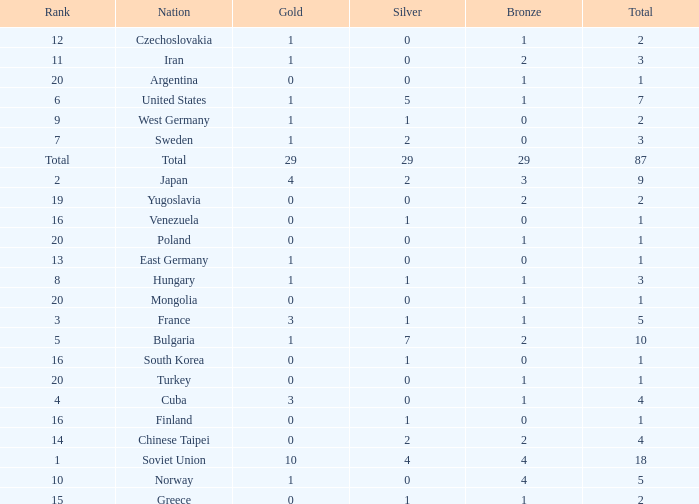What is the average number of bronze medals for total of all nations? 29.0. Could you help me parse every detail presented in this table? {'header': ['Rank', 'Nation', 'Gold', 'Silver', 'Bronze', 'Total'], 'rows': [['12', 'Czechoslovakia', '1', '0', '1', '2'], ['11', 'Iran', '1', '0', '2', '3'], ['20', 'Argentina', '0', '0', '1', '1'], ['6', 'United States', '1', '5', '1', '7'], ['9', 'West Germany', '1', '1', '0', '2'], ['7', 'Sweden', '1', '2', '0', '3'], ['Total', 'Total', '29', '29', '29', '87'], ['2', 'Japan', '4', '2', '3', '9'], ['19', 'Yugoslavia', '0', '0', '2', '2'], ['16', 'Venezuela', '0', '1', '0', '1'], ['20', 'Poland', '0', '0', '1', '1'], ['13', 'East Germany', '1', '0', '0', '1'], ['8', 'Hungary', '1', '1', '1', '3'], ['20', 'Mongolia', '0', '0', '1', '1'], ['3', 'France', '3', '1', '1', '5'], ['5', 'Bulgaria', '1', '7', '2', '10'], ['16', 'South Korea', '0', '1', '0', '1'], ['20', 'Turkey', '0', '0', '1', '1'], ['4', 'Cuba', '3', '0', '1', '4'], ['16', 'Finland', '0', '1', '0', '1'], ['14', 'Chinese Taipei', '0', '2', '2', '4'], ['1', 'Soviet Union', '10', '4', '4', '18'], ['10', 'Norway', '1', '0', '4', '5'], ['15', 'Greece', '0', '1', '1', '2']]} 